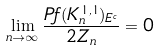Convert formula to latex. <formula><loc_0><loc_0><loc_500><loc_500>\lim _ { n \rightarrow \infty } \frac { P f ( K _ { n } ^ { 1 , 1 } ) _ { E ^ { c } } } { 2 Z _ { n } } = 0</formula> 